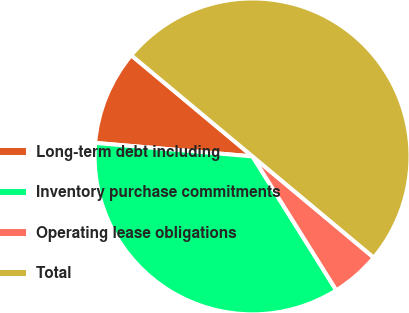<chart> <loc_0><loc_0><loc_500><loc_500><pie_chart><fcel>Long-term debt including<fcel>Inventory purchase commitments<fcel>Operating lease obligations<fcel>Total<nl><fcel>9.7%<fcel>35.26%<fcel>5.03%<fcel>50.01%<nl></chart> 